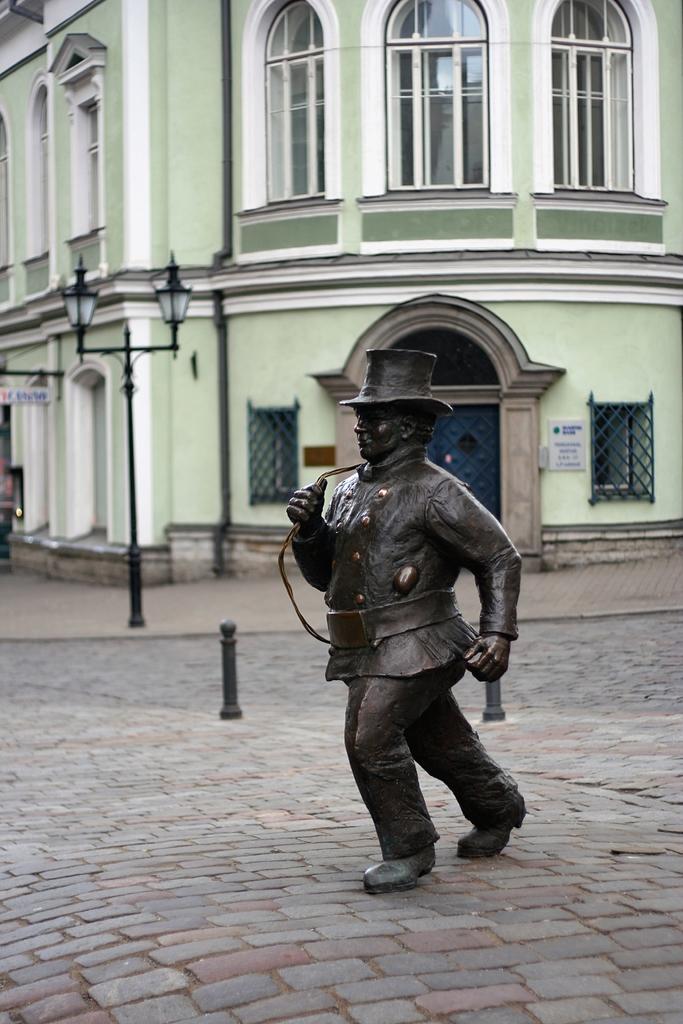Please provide a concise description of this image. In this picture we can see a statue in the front, in the background there is a building, on the left side we can see a pole and lights, we can also see windows and glasses of this building. 